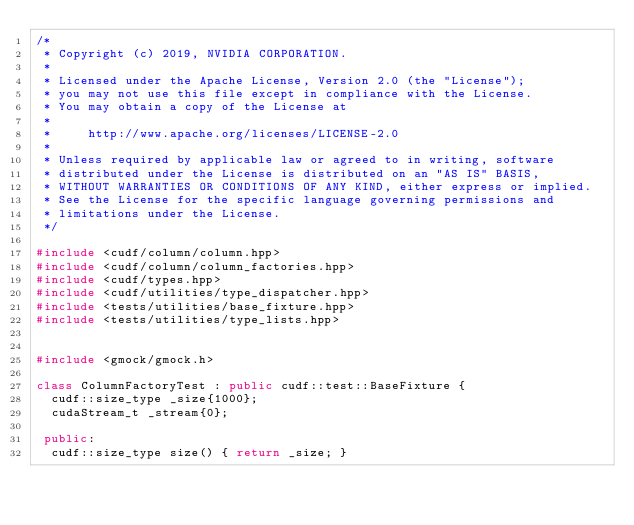<code> <loc_0><loc_0><loc_500><loc_500><_C++_>/*
 * Copyright (c) 2019, NVIDIA CORPORATION.
 *
 * Licensed under the Apache License, Version 2.0 (the "License");
 * you may not use this file except in compliance with the License.
 * You may obtain a copy of the License at
 *
 *     http://www.apache.org/licenses/LICENSE-2.0
 *
 * Unless required by applicable law or agreed to in writing, software
 * distributed under the License is distributed on an "AS IS" BASIS,
 * WITHOUT WARRANTIES OR CONDITIONS OF ANY KIND, either express or implied.
 * See the License for the specific language governing permissions and
 * limitations under the License.
 */

#include <cudf/column/column.hpp>
#include <cudf/column/column_factories.hpp>
#include <cudf/types.hpp>
#include <cudf/utilities/type_dispatcher.hpp>
#include <tests/utilities/base_fixture.hpp>
#include <tests/utilities/type_lists.hpp>


#include <gmock/gmock.h>

class ColumnFactoryTest : public cudf::test::BaseFixture {
  cudf::size_type _size{1000};
  cudaStream_t _stream{0};

 public:
  cudf::size_type size() { return _size; }</code> 